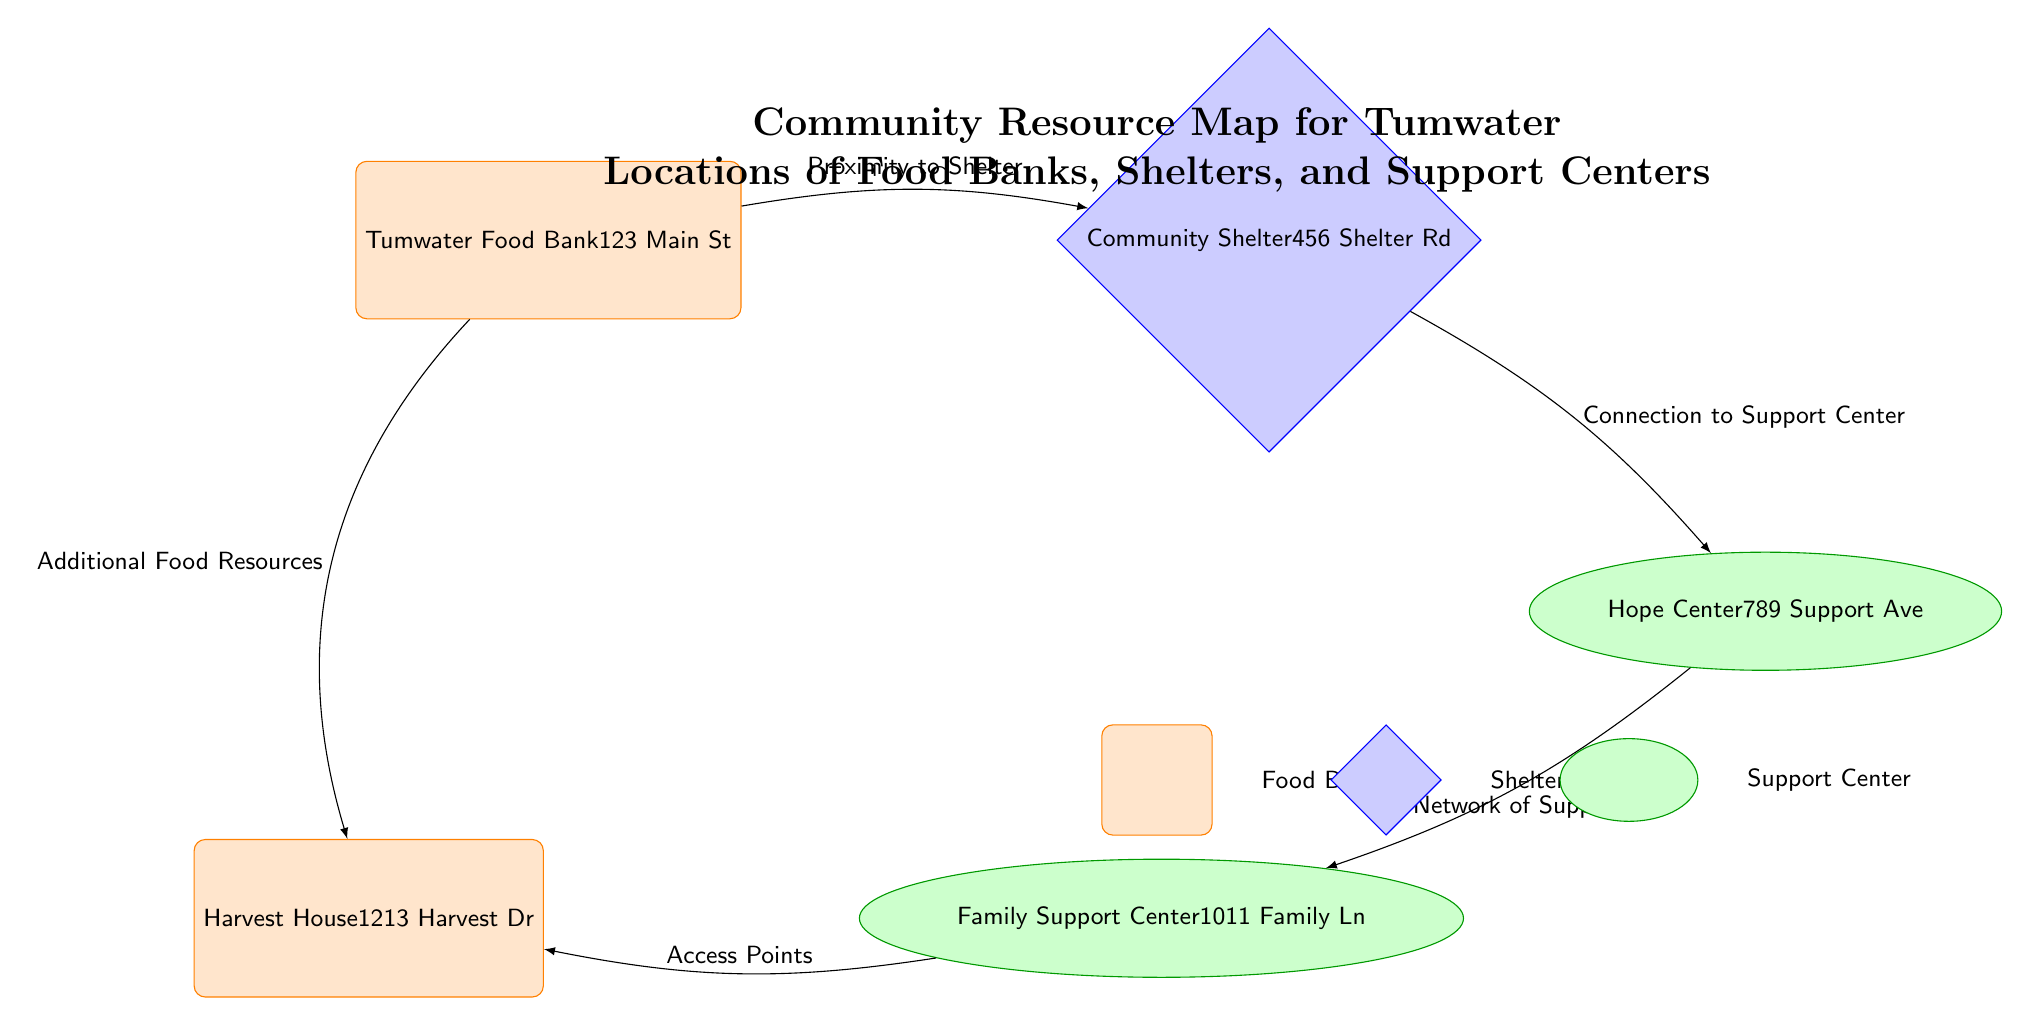What's the address of the Tumwater Food Bank? The diagram shows the node labeled 'Tumwater Food Bank', which provides the address directly beneath it as '123 Main St'.
Answer: 123 Main St How many food banks are listed in the diagram? The diagram displays two specific nodes representing food banks: 'Tumwater Food Bank' and 'Harvest House'. This indicates there are a total of two food banks in the community resource map.
Answer: 2 What type of resource is the 'Hope Center'? By examining the node labeled 'Hope Center', we can see that it is structured as an ellipse, which is designated for support centers in this diagram.
Answer: Support Center What relationship exists between the 'Community Shelter' and the 'Hope Center'? The edge connecting 'Community Shelter' to 'Hope Center' is labeled 'Connection to Support Center', indicating a direct relationship where the shelter connects to the support center.
Answer: Connection to Support Center What additional resource is indicated by the edge from 'Tumwater Food Bank' to 'Harvest House'? The edge going from 'Tumwater Food Bank' to 'Harvest House' is labeled 'Additional Food Resources', suggesting that this edge denotes the presence of extra food resources associated with the food bank.
Answer: Additional Food Resources How many support centers are shown in the diagram? The diagram features two nodes representing support centers: 'Hope Center' and 'Family Support Center'. Thus, there are two support centers shown.
Answer: 2 What is the minimum size of the food bank nodes? Each food bank node in the diagram has been given a specific minimum size attribute of 'minimum size=2cm', which denotes the size assigned to those nodes.
Answer: 2cm Which node is connected to both the 'Community Shelter' and 'Family Support Center'? The 'Hope Center' node is connected to the 'Community Shelter' with the labeled edge 'Connection to Support Center', and it is also connected to 'Family Support Center' through the edge labeled 'Network of Support'.
Answer: Hope Center What indicates the relationship between 'Family Support Center' and 'Harvest House'? The edge from 'Family Support Center' to 'Harvest House' is labeled 'Access Points', which signifies the relationship and interaction between those two resources.
Answer: Access Points 